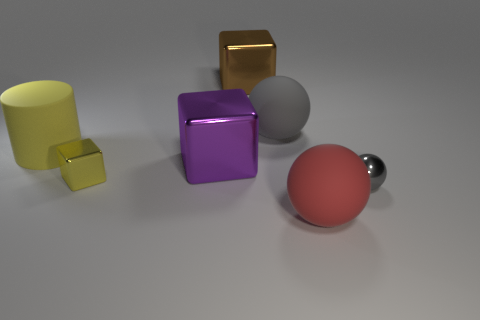How many big objects are the same color as the small metal sphere?
Give a very brief answer. 1. What material is the ball that is the same size as the yellow metallic block?
Your answer should be very brief. Metal. What number of other objects are there of the same color as the small cube?
Your answer should be very brief. 1. Is the large gray object the same shape as the brown shiny object?
Your response must be concise. No. How many small yellow objects are to the right of the gray rubber sphere?
Provide a succinct answer. 0. Does the gray thing to the left of the red thing have the same size as the small yellow metallic thing?
Your answer should be compact. No. What color is the other large object that is the same shape as the gray matte thing?
Ensure brevity in your answer.  Red. Is there anything else that has the same shape as the yellow matte object?
Your answer should be very brief. No. What shape is the small metallic object that is on the left side of the red ball?
Keep it short and to the point. Cube. What number of purple things have the same shape as the yellow metal object?
Give a very brief answer. 1. 